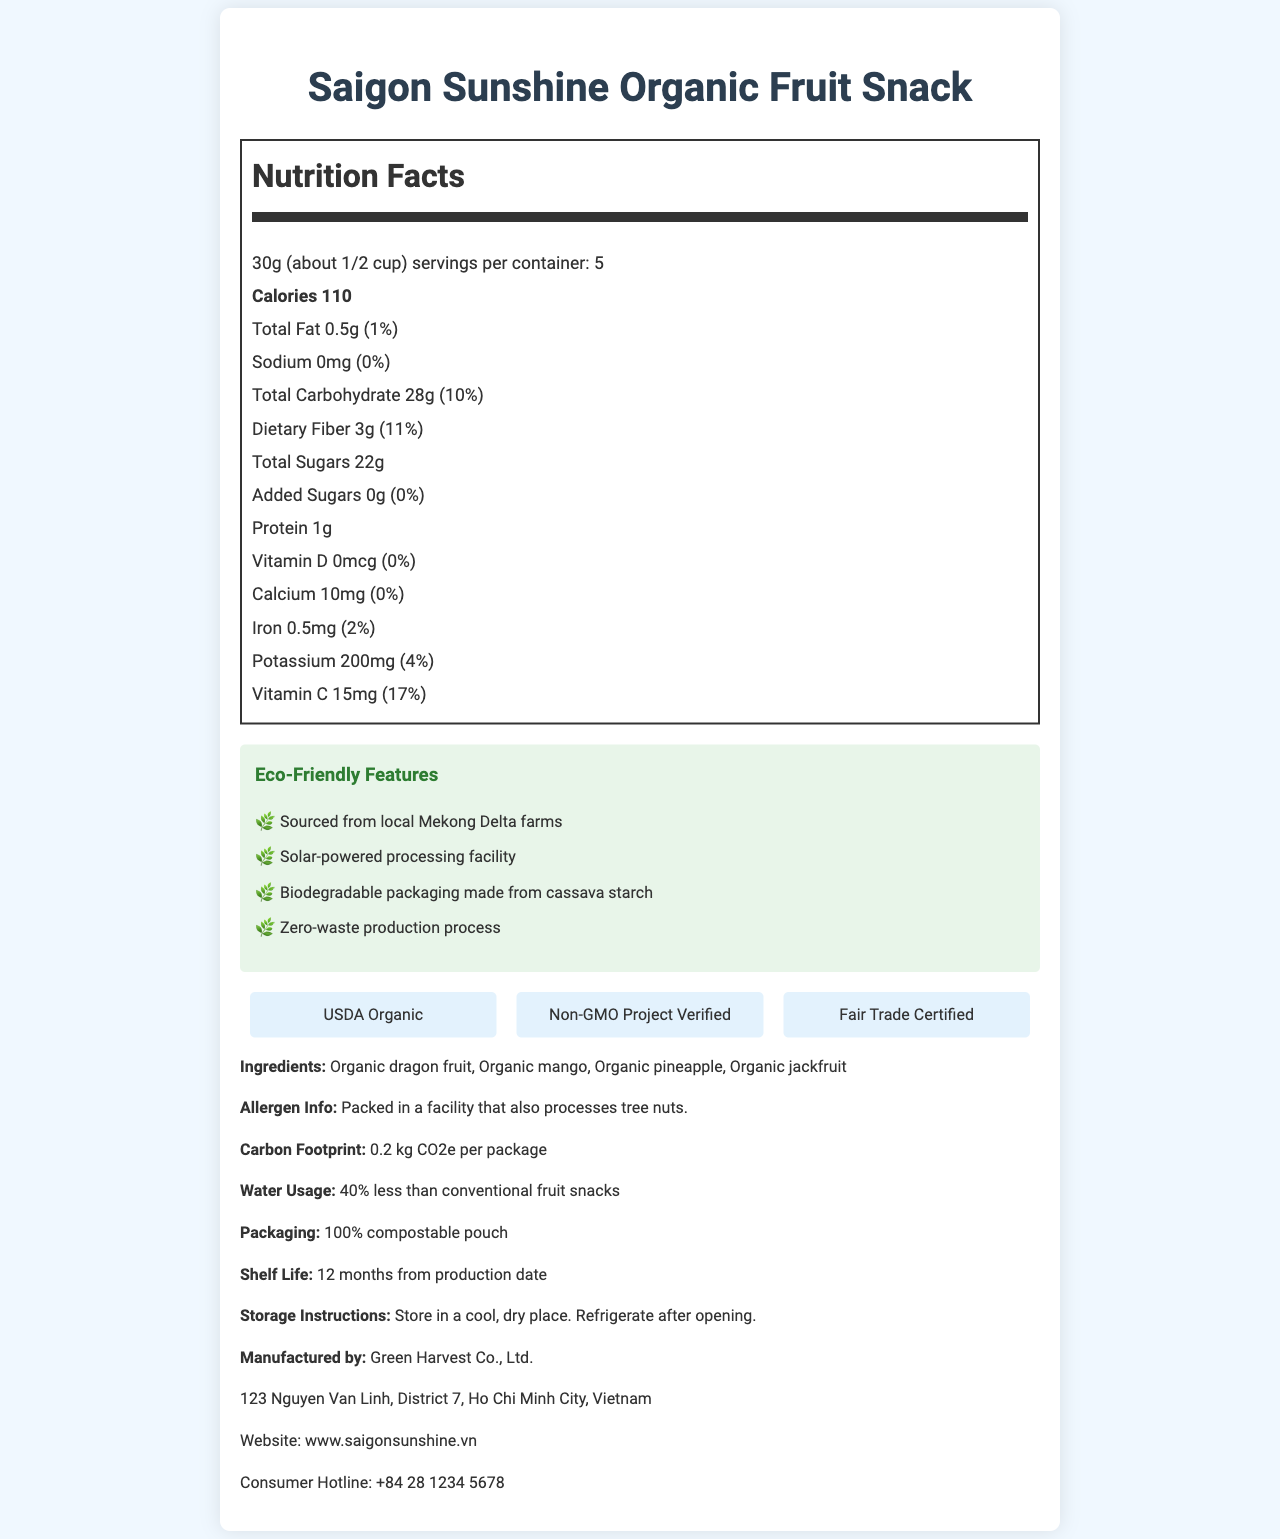what is the serving size for the Saigon Sunshine Organic Fruit Snack? The serving size is clearly indicated at the top of the Nutrition Facts section as "30g (about 1/2 cup)".
Answer: 30g (about 1/2 cup) how many calories are in one serving of the Saigon Sunshine Organic Fruit Snack? The document lists the calorie content as "Calories 110" in the Nutrition Facts section.
Answer: 110 calories which vitamins and minerals are present in the snack? The Nutrition Facts section lists Vitamin D, Calcium, Iron, Potassium, and Vitamin C with their respective amounts and daily values.
Answer: Vitamin D, Calcium, Iron, Potassium, Vitamin C how many grams of dietary fiber are in each serving? Under the Nutrition Facts, it shows "Dietary Fiber 3g (11%)".
Answer: 3g what are the main ingredients in the fruit snack? The ingredients are listed at the bottom of the document under "Ingredients."
Answer: Organic dragon fruit, Organic mango, Organic pineapple, Organic jackfruit where are the fruits for the snack sourced from? Under Eco-Friendly Features, it mentions that the fruits are "Sourced from local Mekong Delta farms."
Answer: Local Mekong Delta farms what is the total carbohydrate content per serving? The Nutrition Facts indicate "Total Carbohydrate 28g (10%)".
Answer: 28g how much added sugar does the snack contain? The document shows "Added Sugars 0g (0%)" under the Total Sugars section.
Answer: 0g what is the shelf life of the Saigon Sunshine Organic Fruit Snack? The document states the shelf life as "12 months from production date".
Answer: 12 months from production date what type of certification is NOT listed for the Saigon Sunshine Organic Fruit Snack? A. USDA Organic B. Gluten-Free Certified C. Non-GMO Project Verified D. Fair Trade Certified The certifications listed are "USDA Organic," "Non-GMO Project Verified," and "Fair Trade Certified"; "Gluten-Free Certified" is not mentioned.
Answer: B. Gluten-Free Certified which of the following is an environmental feature of the product's packaging? A. Recyclable plastic B. 100% compostable pouch C. Made from recycled materials The packaging is described as "100% compostable pouch" under Eco-Friendly Features.
Answer: B. 100% compostable pouch is the Saigon Sunshine Organic Fruit Snack suitable for people with nut allergies? The allergen information states that it is "Packed in a facility that also processes tree nuts," which may not be safe for people with nut allergies.
Answer: No what is the carbon footprint per package of this fruit snack? The document indicates the carbon footprint as "0.2 kg CO2e per package".
Answer: 0.2 kg CO2e per package what are the eco-friendly features of the Saigon Sunshine Organic Fruit Snack? The Eco-Friendly Features section lists these items explicitly.
Answer: Sourced from local Mekong Delta farms, Solar-powered processing facility, Biodegradable packaging made from cassava starch, Zero-waste production process what is the full address of the manufacturer? The manufacturer's address is listed at the bottom of the document.
Answer: 123 Nguyen Van Linh, District 7, Ho Chi Minh City, Vietnam who is the manufacturer of the Saigon Sunshine Organic Fruit Snack? The manufacturer is indicated as "Green Harvest Co., Ltd." at the end of the document.
Answer: Green Harvest Co., Ltd. summarize the main environmental and nutritional benefits of the Saigon Sunshine Organic Fruit Snack. This document emphasizes the snack's health benefits, such as high dietary fiber and essential vitamins, while also highlighting its environmental credentials, including local sourcing, zero-waste production, and compostable packaging.
Answer: The Saigon Sunshine Organic Fruit Snack is a locally-sourced, eco-friendly option with low calories and high nutritional value. It is made from organic fruits from Mekong Delta farms, processed in a solar-powered facility, and packaged in biodegradable material. The snack contains essential nutrients like dietary fiber, vitamin C, and potassium, while being low in fat and sugar-free. does the snack contain any gluten? The document does not provide any information about gluten content.
Answer: Not enough information 